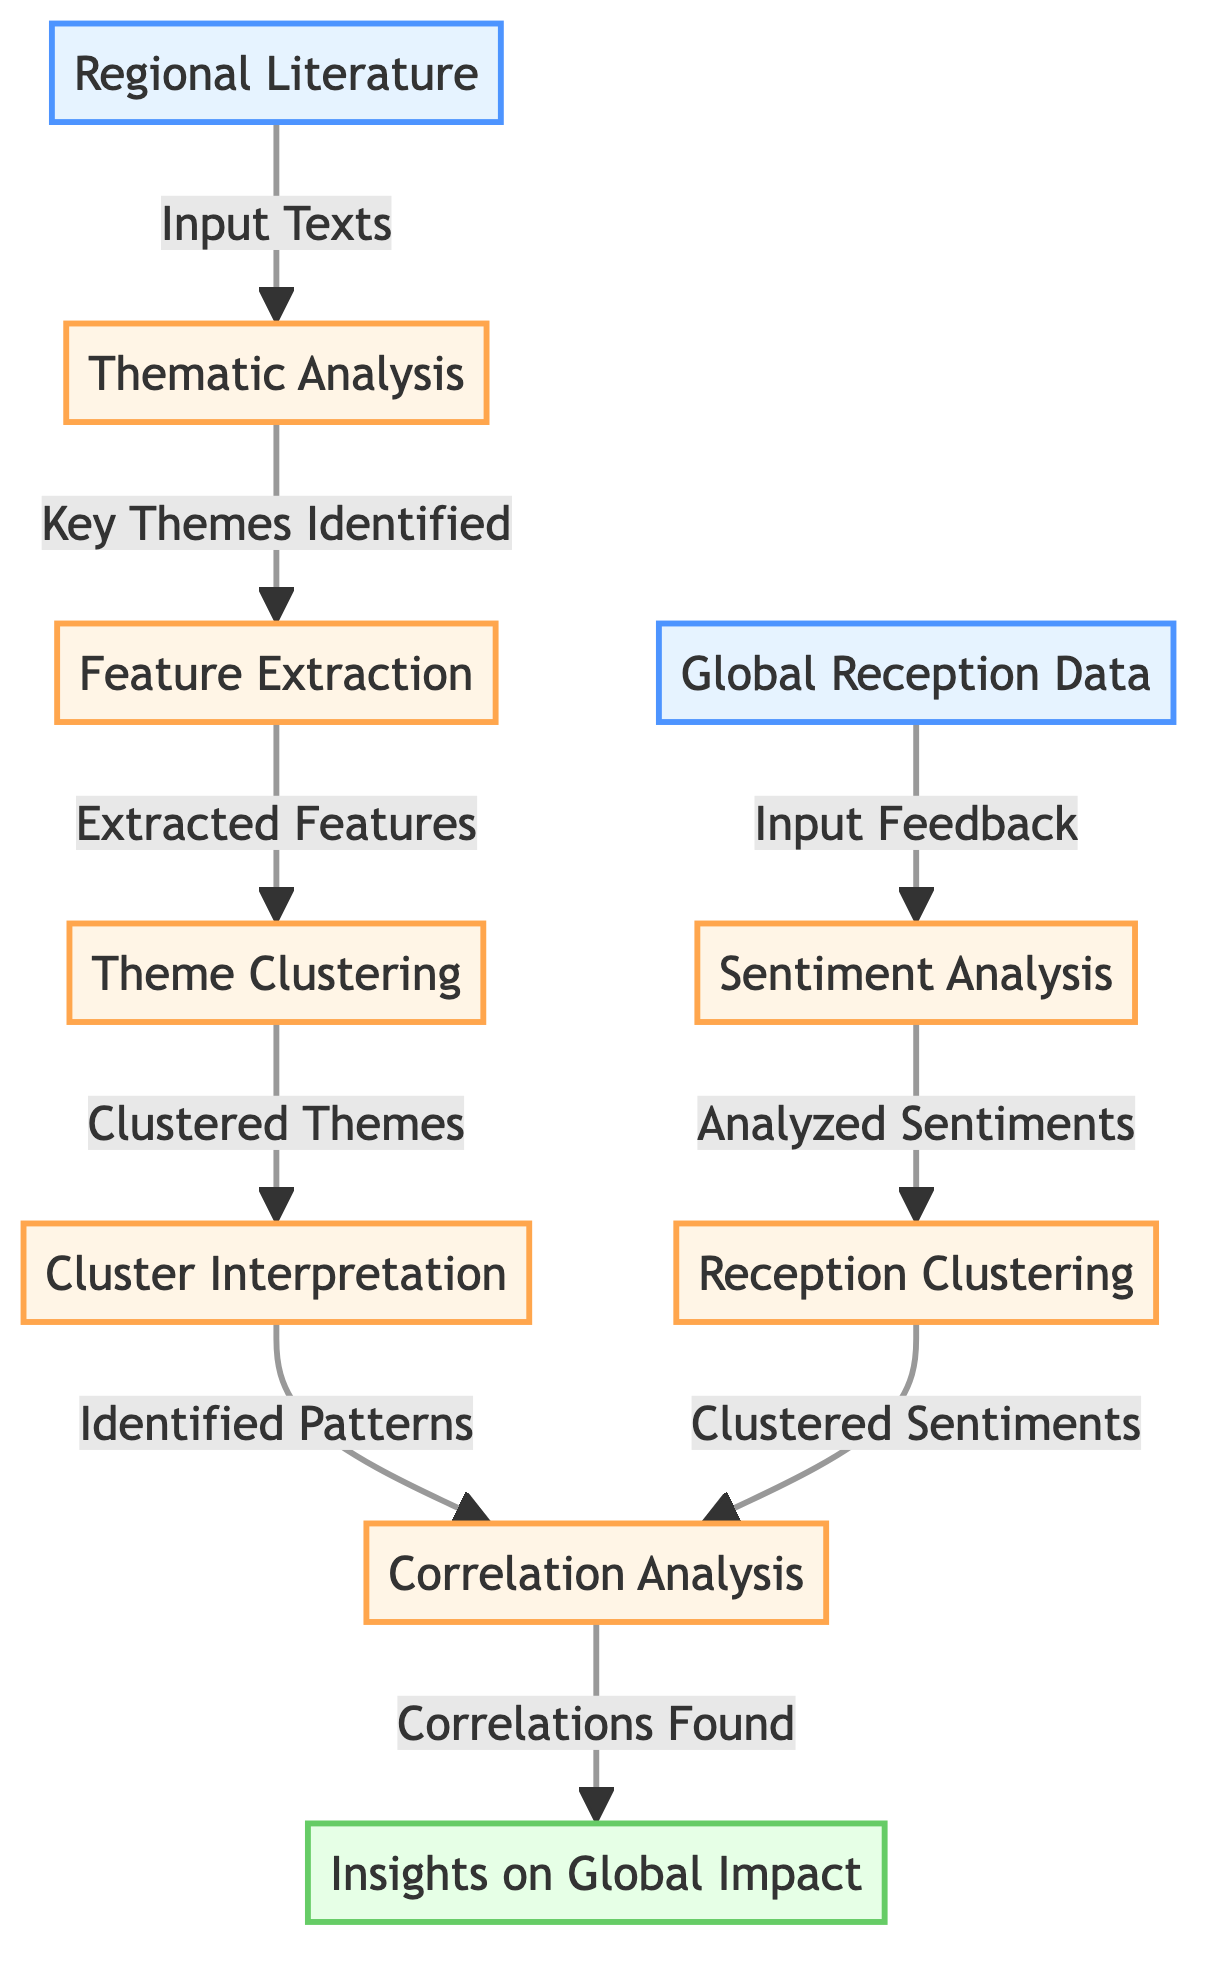What is the first node in the diagram? The first node in the diagram is labeled "Regional Literature." It serves as the initial input for the entire process.
Answer: Regional Literature How many main processes are involved in theme analysis? Counting the processes in the diagram, there are five main processes: Thematic Analysis, Feature Extraction, Theme Clustering, Cluster Interpretation, and Sentiment Analysis.
Answer: Five Which node receives input from "Global Reception Data"? The node that receives input from "Global Reception Data" is "Sentiment Analysis," which indicates it's the next step after receiving feedback data.
Answer: Sentiment Analysis What follows "Cluster Interpretation" in the flow? Following "Cluster Interpretation," the next step is "Correlation Analysis," connecting the findings from theme clustering to global impact insights.
Answer: Correlation Analysis How many clusters are formed from the themes and sentiments? The diagram does not specify an exact number of clusters formed; however, it implies multiple clusters for both themes and sentiments created in the "Theme Clustering" and "Reception Clustering" processes.
Answer: Multiple Which two processes are linked to "Correlation Analysis"? The two processes linked to "Correlation Analysis" are "Theme Clustering" and "Reception Clustering." They provide the necessary data for analyzing correlations of themes and sentiments.
Answer: Theme Clustering and Reception Clustering What is the final output of the diagram? The final output of the diagram is labeled "Insights on Global Impact," which summarizes the results from the correlation analysis step.
Answer: Insights on Global Impact What is the purpose of "Feature Extraction"? The purpose of "Feature Extraction" is to convert key themes identified during thematic analysis into extracted features for clustering purposes.
Answer: Extracted Features Which process involves analyzing received feedback? The process that involves analyzing received feedback is "Sentiment Analysis," which assesses the emotional responses to the regional literature.
Answer: Sentiment Analysis 